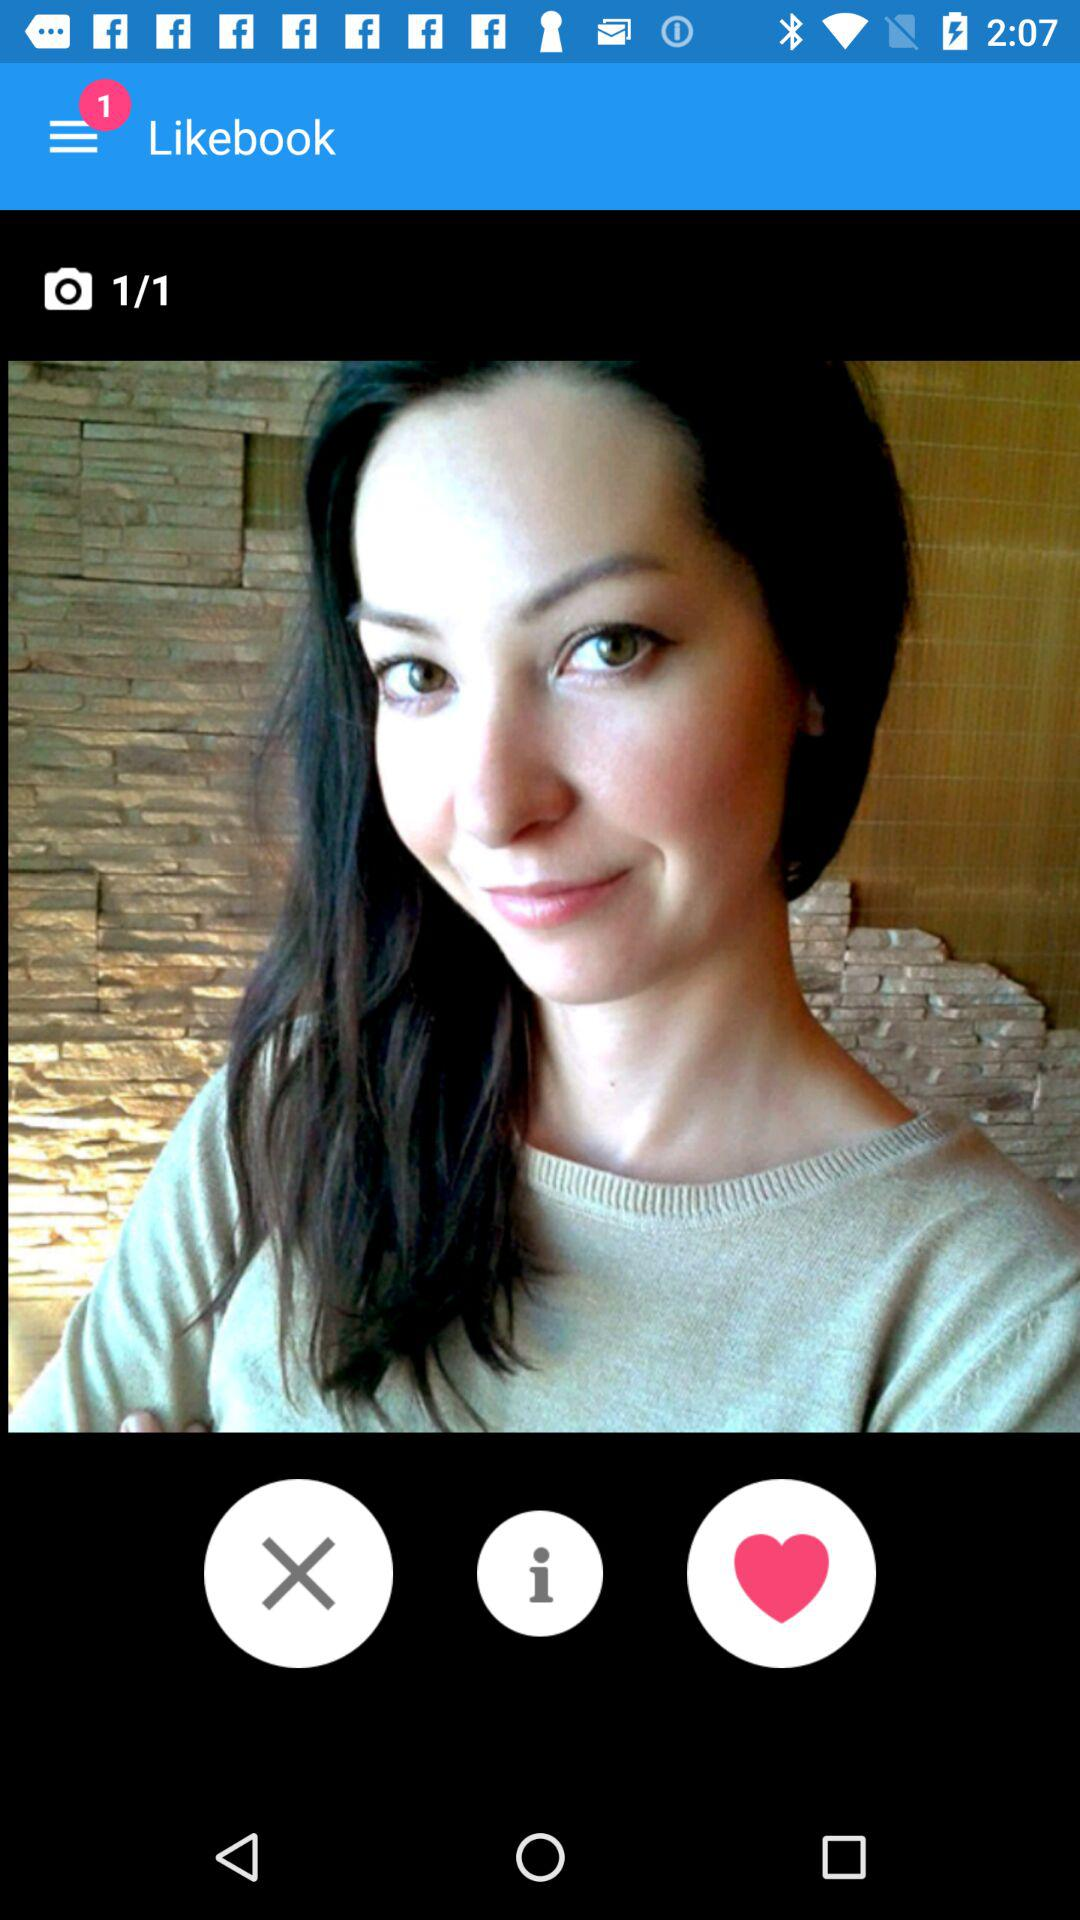How many notifications are there? There is 1 notification. 